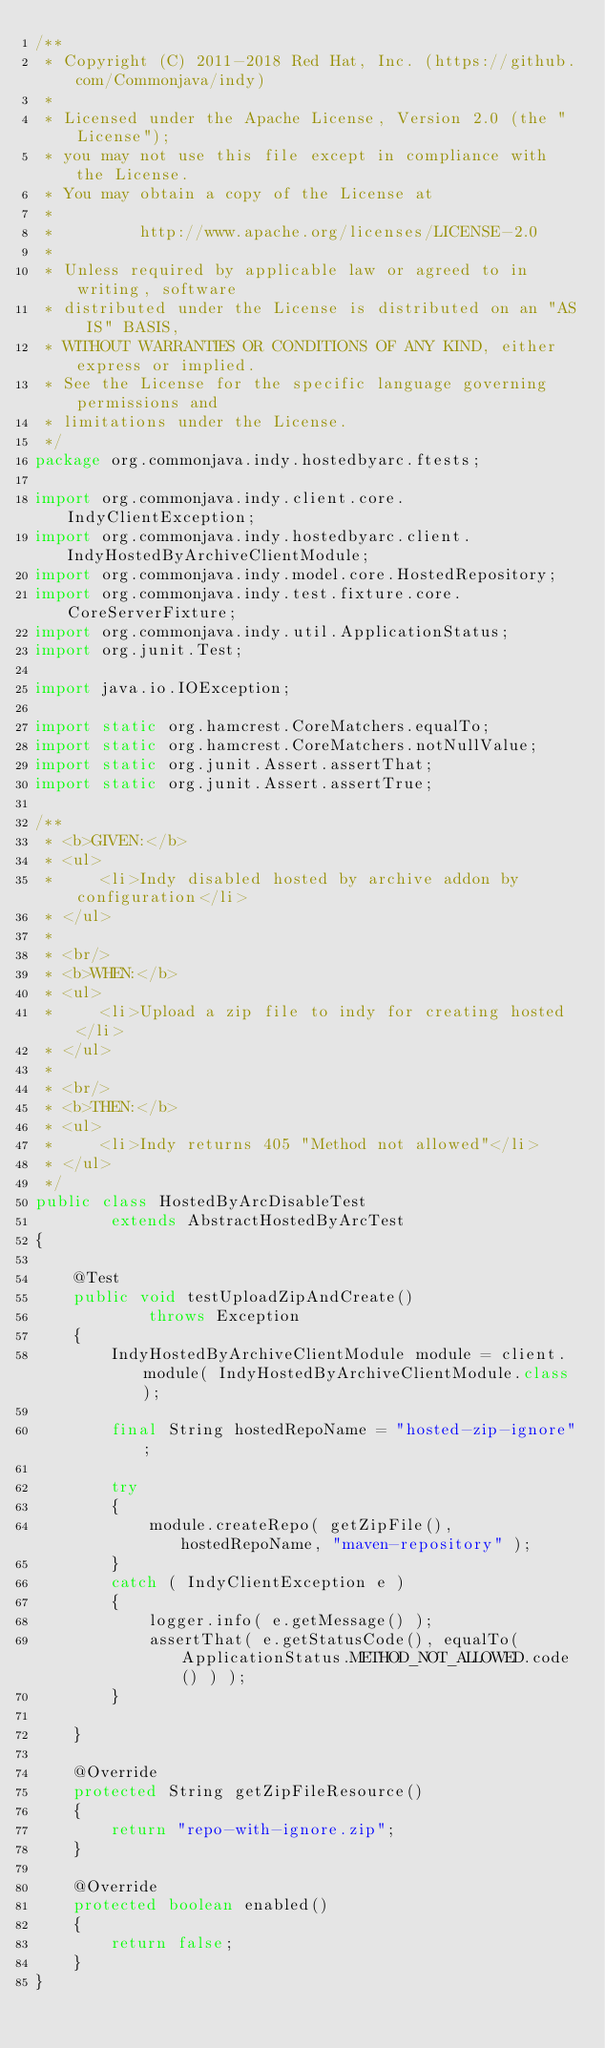<code> <loc_0><loc_0><loc_500><loc_500><_Java_>/**
 * Copyright (C) 2011-2018 Red Hat, Inc. (https://github.com/Commonjava/indy)
 *
 * Licensed under the Apache License, Version 2.0 (the "License");
 * you may not use this file except in compliance with the License.
 * You may obtain a copy of the License at
 *
 *         http://www.apache.org/licenses/LICENSE-2.0
 *
 * Unless required by applicable law or agreed to in writing, software
 * distributed under the License is distributed on an "AS IS" BASIS,
 * WITHOUT WARRANTIES OR CONDITIONS OF ANY KIND, either express or implied.
 * See the License for the specific language governing permissions and
 * limitations under the License.
 */
package org.commonjava.indy.hostedbyarc.ftests;

import org.commonjava.indy.client.core.IndyClientException;
import org.commonjava.indy.hostedbyarc.client.IndyHostedByArchiveClientModule;
import org.commonjava.indy.model.core.HostedRepository;
import org.commonjava.indy.test.fixture.core.CoreServerFixture;
import org.commonjava.indy.util.ApplicationStatus;
import org.junit.Test;

import java.io.IOException;

import static org.hamcrest.CoreMatchers.equalTo;
import static org.hamcrest.CoreMatchers.notNullValue;
import static org.junit.Assert.assertThat;
import static org.junit.Assert.assertTrue;

/**
 * <b>GIVEN:</b>
 * <ul>
 *     <li>Indy disabled hosted by archive addon by configuration</li>
 * </ul>
 *
 * <br/>
 * <b>WHEN:</b>
 * <ul>
 *     <li>Upload a zip file to indy for creating hosted</li>
 * </ul>
 *
 * <br/>
 * <b>THEN:</b>
 * <ul>
 *     <li>Indy returns 405 "Method not allowed"</li>
 * </ul>
 */
public class HostedByArcDisableTest
        extends AbstractHostedByArcTest
{

    @Test
    public void testUploadZipAndCreate()
            throws Exception
    {
        IndyHostedByArchiveClientModule module = client.module( IndyHostedByArchiveClientModule.class );

        final String hostedRepoName = "hosted-zip-ignore";

        try
        {
            module.createRepo( getZipFile(), hostedRepoName, "maven-repository" );
        }
        catch ( IndyClientException e )
        {
            logger.info( e.getMessage() );
            assertThat( e.getStatusCode(), equalTo( ApplicationStatus.METHOD_NOT_ALLOWED.code() ) );
        }

    }

    @Override
    protected String getZipFileResource()
    {
        return "repo-with-ignore.zip";
    }

    @Override
    protected boolean enabled()
    {
        return false;
    }
}
</code> 